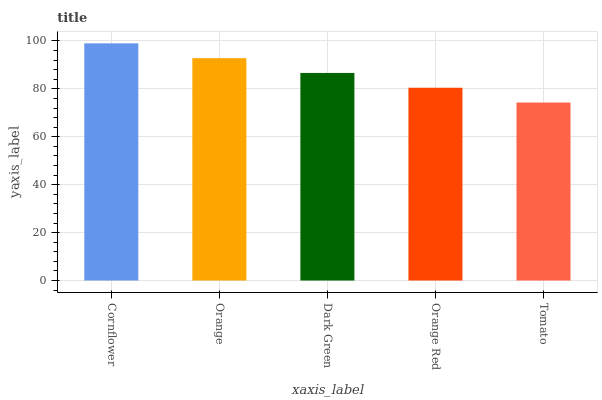Is Tomato the minimum?
Answer yes or no. Yes. Is Cornflower the maximum?
Answer yes or no. Yes. Is Orange the minimum?
Answer yes or no. No. Is Orange the maximum?
Answer yes or no. No. Is Cornflower greater than Orange?
Answer yes or no. Yes. Is Orange less than Cornflower?
Answer yes or no. Yes. Is Orange greater than Cornflower?
Answer yes or no. No. Is Cornflower less than Orange?
Answer yes or no. No. Is Dark Green the high median?
Answer yes or no. Yes. Is Dark Green the low median?
Answer yes or no. Yes. Is Cornflower the high median?
Answer yes or no. No. Is Orange the low median?
Answer yes or no. No. 